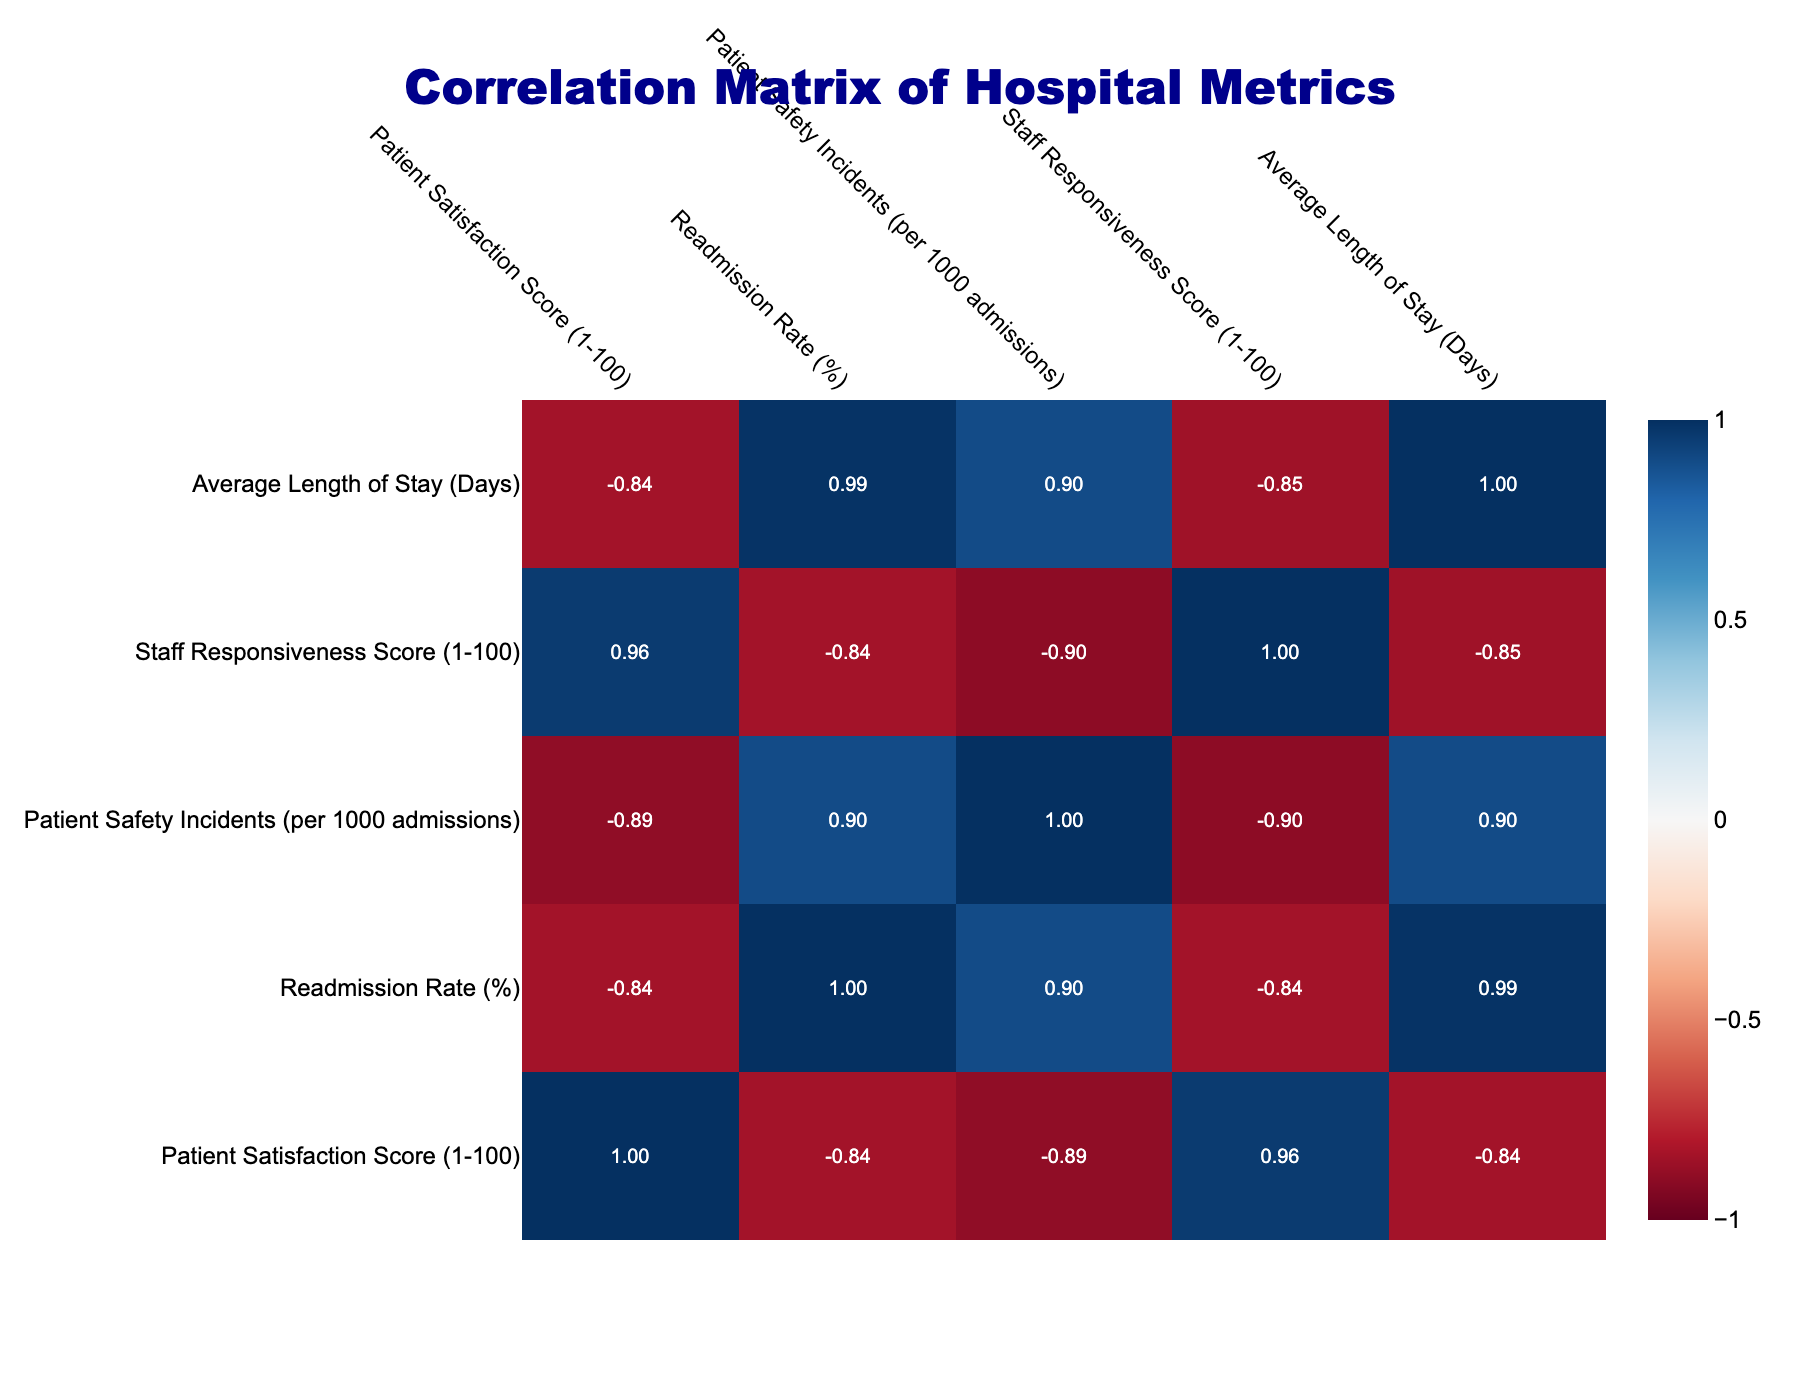What is the Patient Satisfaction Score for Mountainview Hospitals? The table lists the Patient Satisfaction Score alongside each hospital name. For Mountainview Hospitals, the score is found in the relevant row under the corresponding column. Upon examining the table, the score for Mountainview Hospitals is 94.
Answer: 94 What is the Readmission Rate for Green Valley Hospital? To find the Readmission Rate for Green Valley Hospital, refer to the row for Green Valley Hospital and locate the specific column for Readmission Rate. The Readmission Rate for Green Valley Hospital is 8.1%.
Answer: 8.1% Which hospital has the highest Staff Responsiveness Score? By reviewing the Staff Responsiveness Scores in the table, we need to identify the scores across different hospitals. The highest score among the listed hospitals is found for Mountainview Hospitals, which has a score of 89.
Answer: 89 Is the Average Length of Stay at Riverdale Community Hospital greater than 4 days? We can find the Average Length of Stay for Riverdale Community Hospital in the corresponding row. The value listed is 3.9 days, which is less than 4 days, making the statement false.
Answer: No What is the correlation between Patient Satisfaction Score and Readmission Rate? To determine the correlation, look at the correlation table (not displayed here), focusing on the respective row and column for Patient Satisfaction Score and Readmission Rate. The correlation indicates a negative relationship, which means as patient satisfaction scores increase, the readmission rates tend to decrease. This correlation is often expected in healthcare settings.
Answer: Negative correlation What is the average Patient Satisfaction Score for the hospitals listed? First, sum the Patient Satisfaction Scores for all hospitals: 85 + 90 + 75 + 88 + 80 + 94 + 78 + 82 + 87 + 79 =  928. There are 10 hospitals, so to find the average, divide the total score by the number of hospitals: 928 / 10 = 92.8.
Answer: 92.8 Do Seaside Health Center and Hilltop Healthcare Facility have a Patient Satisfaction Score below 80? Check the Patient Satisfaction Scores for both hospitals. The scores for Seaside Health Center and Hilltop Healthcare Facility are 78 and 79, respectively, which means both are below 80. Thus, the statement is true.
Answer: Yes Which hospital and metric show the lowest value in the table? Examining the values for each hospital and metric, we need to identify the minimum value throughout the entire table. The lowest value is 1.0 for Patient Safety Incidents at Lakeside Medical Institute. This is isolated from all other metrics examined.
Answer: 1.0### 